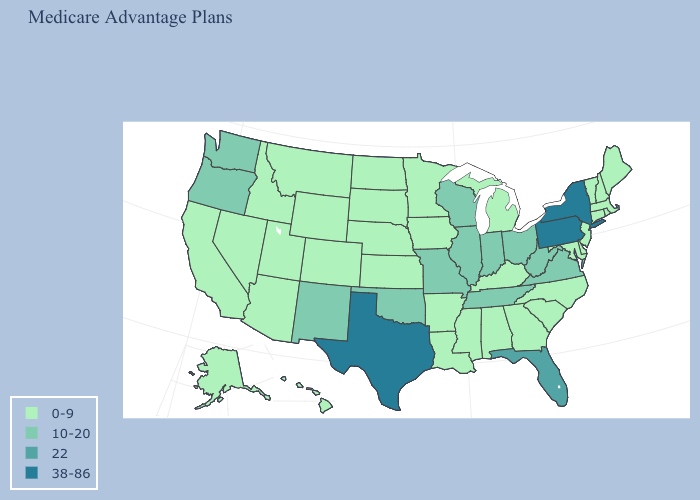Is the legend a continuous bar?
Short answer required. No. What is the value of Indiana?
Keep it brief. 10-20. What is the value of Alaska?
Answer briefly. 0-9. Which states have the lowest value in the USA?
Keep it brief. Alaska, Alabama, Arkansas, Arizona, California, Colorado, Connecticut, Delaware, Georgia, Hawaii, Iowa, Idaho, Kansas, Kentucky, Louisiana, Massachusetts, Maryland, Maine, Michigan, Minnesota, Mississippi, Montana, North Carolina, North Dakota, Nebraska, New Hampshire, New Jersey, Nevada, Rhode Island, South Carolina, South Dakota, Utah, Vermont, Wyoming. Name the states that have a value in the range 0-9?
Write a very short answer. Alaska, Alabama, Arkansas, Arizona, California, Colorado, Connecticut, Delaware, Georgia, Hawaii, Iowa, Idaho, Kansas, Kentucky, Louisiana, Massachusetts, Maryland, Maine, Michigan, Minnesota, Mississippi, Montana, North Carolina, North Dakota, Nebraska, New Hampshire, New Jersey, Nevada, Rhode Island, South Carolina, South Dakota, Utah, Vermont, Wyoming. Name the states that have a value in the range 22?
Be succinct. Florida. Name the states that have a value in the range 38-86?
Keep it brief. New York, Pennsylvania, Texas. What is the lowest value in the South?
Keep it brief. 0-9. Which states have the highest value in the USA?
Be succinct. New York, Pennsylvania, Texas. Name the states that have a value in the range 0-9?
Be succinct. Alaska, Alabama, Arkansas, Arizona, California, Colorado, Connecticut, Delaware, Georgia, Hawaii, Iowa, Idaho, Kansas, Kentucky, Louisiana, Massachusetts, Maryland, Maine, Michigan, Minnesota, Mississippi, Montana, North Carolina, North Dakota, Nebraska, New Hampshire, New Jersey, Nevada, Rhode Island, South Carolina, South Dakota, Utah, Vermont, Wyoming. Name the states that have a value in the range 0-9?
Short answer required. Alaska, Alabama, Arkansas, Arizona, California, Colorado, Connecticut, Delaware, Georgia, Hawaii, Iowa, Idaho, Kansas, Kentucky, Louisiana, Massachusetts, Maryland, Maine, Michigan, Minnesota, Mississippi, Montana, North Carolina, North Dakota, Nebraska, New Hampshire, New Jersey, Nevada, Rhode Island, South Carolina, South Dakota, Utah, Vermont, Wyoming. Does West Virginia have the lowest value in the South?
Give a very brief answer. No. What is the highest value in states that border Georgia?
Quick response, please. 22. What is the highest value in states that border Montana?
Quick response, please. 0-9. Among the states that border Alabama , which have the lowest value?
Quick response, please. Georgia, Mississippi. 